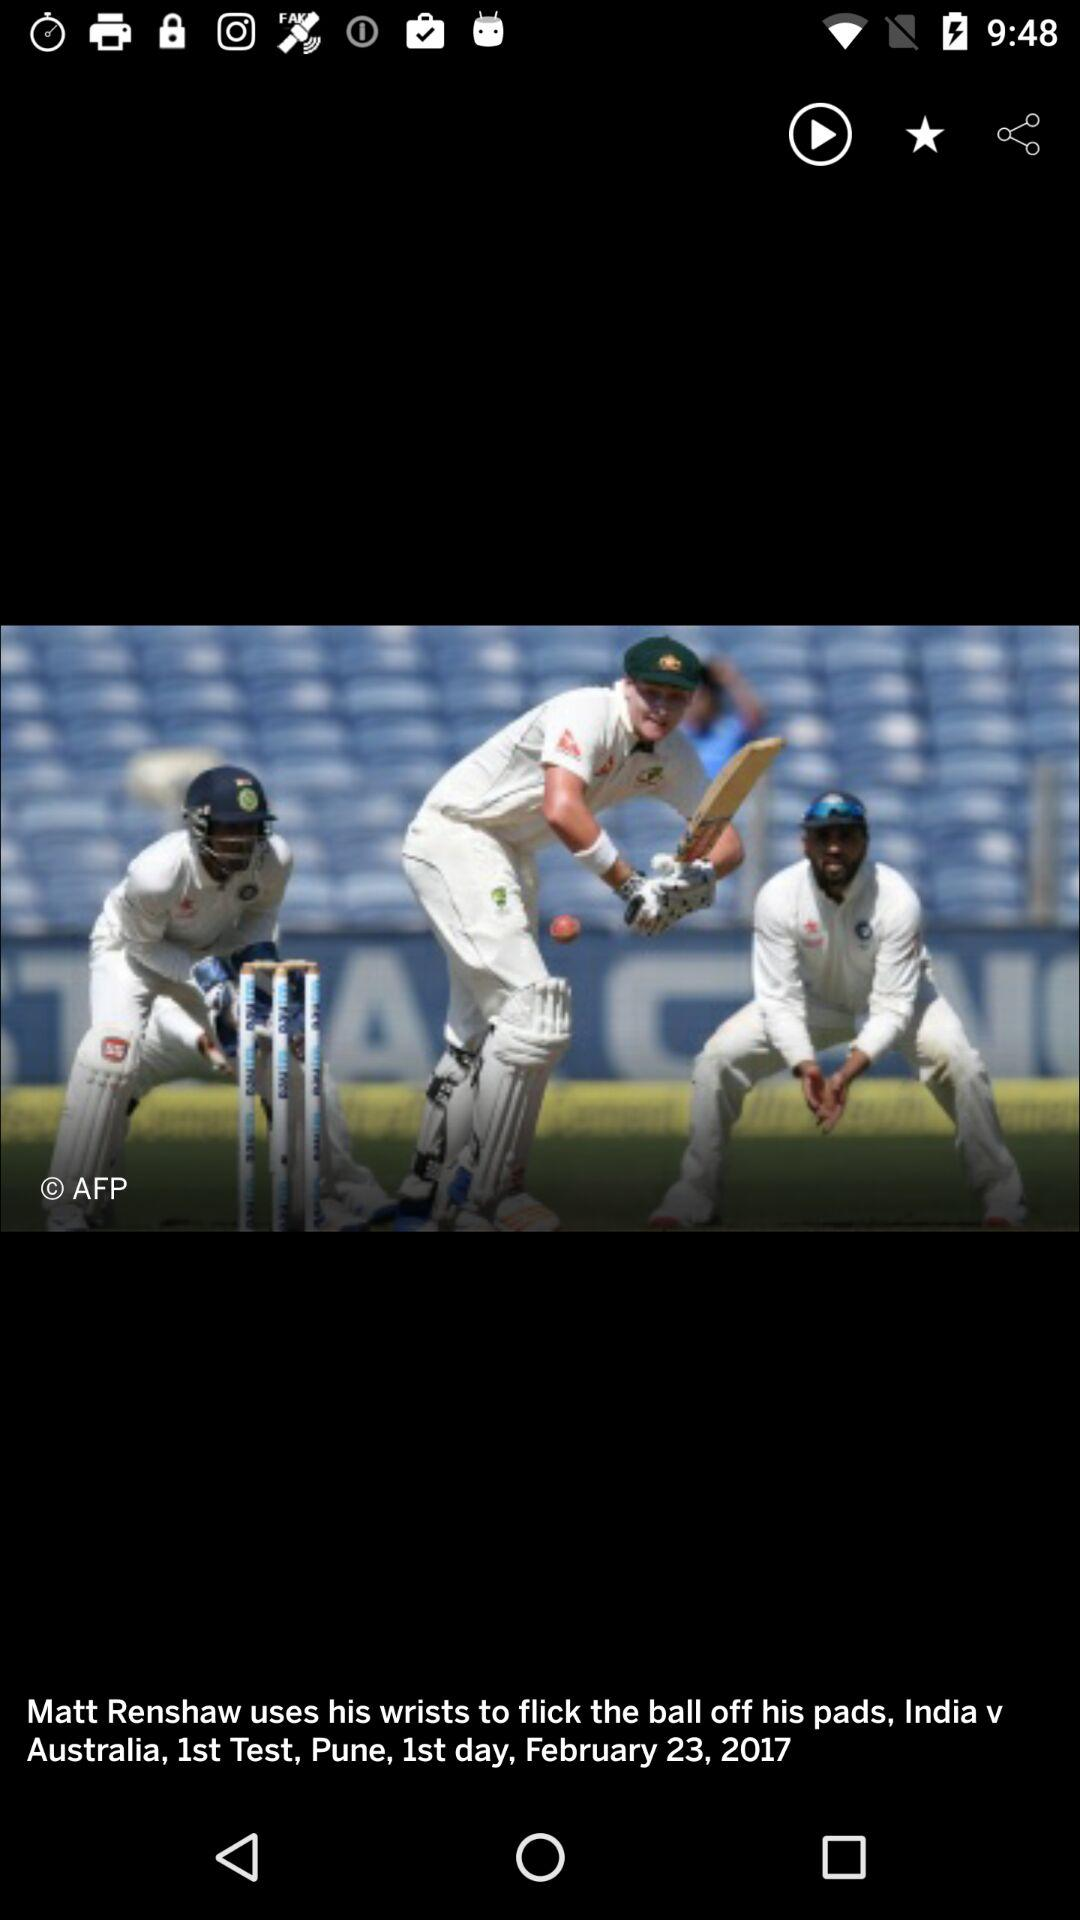Which is the day of the match? It is 1st day of the match. 